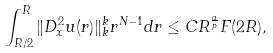Convert formula to latex. <formula><loc_0><loc_0><loc_500><loc_500>\int _ { R / 2 } ^ { R } \| D _ { x } ^ { 2 } u ( r ) \| ^ { k } _ { k } r ^ { N - 1 } d r \leq C R ^ { \frac { a } { p } } F ( 2 R ) ,</formula> 